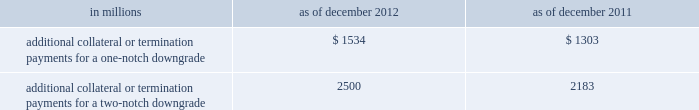Management 2019s discussion and analysis we believe our credit ratings are primarily based on the credit rating agencies 2019 assessment of : 2030 our liquidity , market , credit and operational risk management practices ; 2030 the level and variability of our earnings ; 2030 our capital base ; 2030 our franchise , reputation and management ; 2030 our corporate governance ; and 2030 the external operating environment , including the assumed level of government support .
Certain of the firm 2019s derivatives have been transacted under bilateral agreements with counterparties who may require us to post collateral or terminate the transactions based on changes in our credit ratings .
We assess the impact of these bilateral agreements by determining the collateral or termination payments that would occur assuming a downgrade by all rating agencies .
A downgrade by any one rating agency , depending on the agency 2019s relative ratings of the firm at the time of the downgrade , may have an impact which is comparable to the impact of a downgrade by all rating agencies .
We allocate a portion of our gce to ensure we would be able to make the additional collateral or termination payments that may be required in the event of a two-notch reduction in our long-term credit ratings , as well as collateral that has not been called by counterparties , but is available to them .
The table below presents the additional collateral or termination payments that could have been called at the reporting date by counterparties in the event of a one-notch and two-notch downgrade in our credit ratings. .
In millions 2012 2011 additional collateral or termination payments for a one-notch downgrade $ 1534 $ 1303 additional collateral or termination payments for a two-notch downgrade 2500 2183 cash flows as a global financial institution , our cash flows are complex and bear little relation to our net earnings and net assets .
Consequently , we believe that traditional cash flow analysis is less meaningful in evaluating our liquidity position than the excess liquidity and asset-liability management policies described above .
Cash flow analysis may , however , be helpful in highlighting certain macro trends and strategic initiatives in our businesses .
Year ended december 2012 .
Our cash and cash equivalents increased by $ 16.66 billion to $ 72.67 billion at the end of 2012 .
We generated $ 9.14 billion in net cash from operating and investing activities .
We generated $ 7.52 billion in net cash from financing activities from an increase in bank deposits , partially offset by net repayments of unsecured and secured long-term borrowings .
Year ended december 2011 .
Our cash and cash equivalents increased by $ 16.22 billion to $ 56.01 billion at the end of 2011 .
We generated $ 23.13 billion in net cash from operating and investing activities .
We used net cash of $ 6.91 billion for financing activities , primarily for repurchases of our series g preferred stock and common stock , partially offset by an increase in bank deposits .
Year ended december 2010 .
Our cash and cash equivalents increased by $ 1.50 billion to $ 39.79 billion at the end of 2010 .
We generated $ 7.84 billion in net cash from financing activities primarily from net proceeds from issuances of short-term secured financings .
We used net cash of $ 6.34 billion for operating and investing activities , primarily to fund an increase in securities purchased under agreements to resell and an increase in cash and securities segregated for regulatory and other purposes , partially offset by cash generated from a decrease in securities borrowed .
Goldman sachs 2012 annual report 87 .
What is the percentage of additional collateral or termination payments for a two-notch downgrade over additional collateral or termination payments for a one-notch downgrade for 2012? 
Computations: ((2500 - 1534) / 1534)
Answer: 0.62973. 